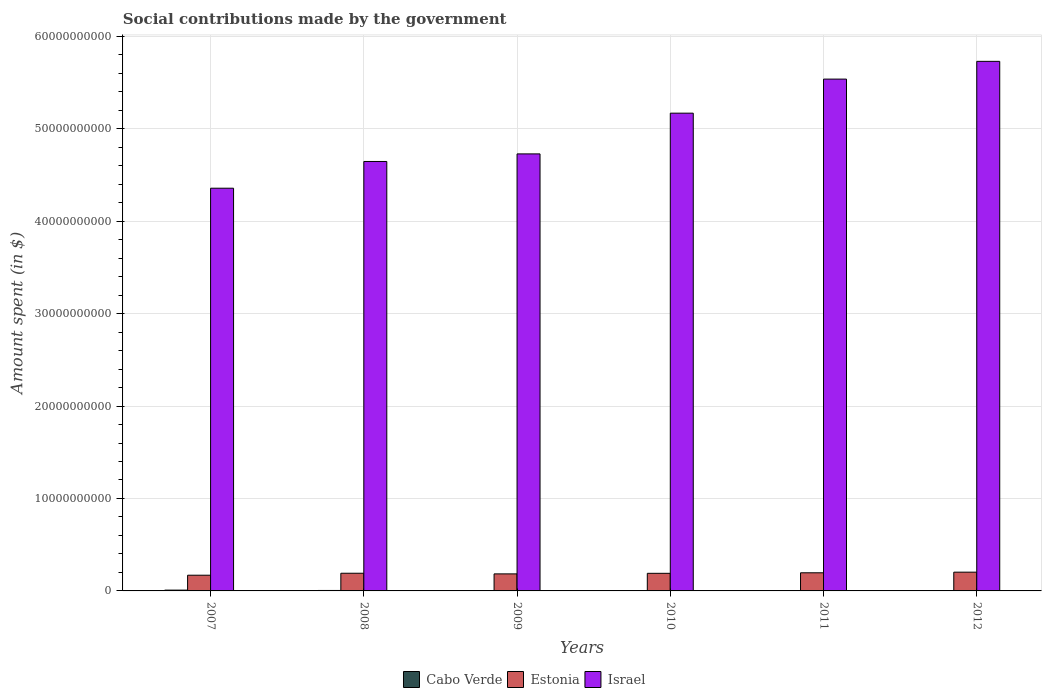How many different coloured bars are there?
Keep it short and to the point. 3. Are the number of bars per tick equal to the number of legend labels?
Keep it short and to the point. Yes. Are the number of bars on each tick of the X-axis equal?
Provide a short and direct response. Yes. How many bars are there on the 6th tick from the right?
Your answer should be compact. 3. What is the label of the 5th group of bars from the left?
Offer a very short reply. 2011. In how many cases, is the number of bars for a given year not equal to the number of legend labels?
Offer a terse response. 0. What is the amount spent on social contributions in Israel in 2009?
Offer a very short reply. 4.73e+1. Across all years, what is the maximum amount spent on social contributions in Cabo Verde?
Give a very brief answer. 8.65e+07. Across all years, what is the minimum amount spent on social contributions in Cabo Verde?
Give a very brief answer. 1.29e+07. In which year was the amount spent on social contributions in Israel maximum?
Your response must be concise. 2012. In which year was the amount spent on social contributions in Estonia minimum?
Make the answer very short. 2007. What is the total amount spent on social contributions in Estonia in the graph?
Provide a short and direct response. 1.13e+1. What is the difference between the amount spent on social contributions in Cabo Verde in 2009 and that in 2011?
Your answer should be compact. 9.01e+06. What is the difference between the amount spent on social contributions in Cabo Verde in 2011 and the amount spent on social contributions in Estonia in 2010?
Give a very brief answer. -1.87e+09. What is the average amount spent on social contributions in Estonia per year?
Offer a terse response. 1.89e+09. In the year 2011, what is the difference between the amount spent on social contributions in Cabo Verde and amount spent on social contributions in Israel?
Your answer should be compact. -5.53e+1. In how many years, is the amount spent on social contributions in Estonia greater than 26000000000 $?
Keep it short and to the point. 0. What is the ratio of the amount spent on social contributions in Estonia in 2008 to that in 2009?
Make the answer very short. 1.04. Is the difference between the amount spent on social contributions in Cabo Verde in 2008 and 2009 greater than the difference between the amount spent on social contributions in Israel in 2008 and 2009?
Ensure brevity in your answer.  Yes. What is the difference between the highest and the second highest amount spent on social contributions in Israel?
Make the answer very short. 1.92e+09. What is the difference between the highest and the lowest amount spent on social contributions in Cabo Verde?
Offer a very short reply. 7.36e+07. What does the 2nd bar from the left in 2008 represents?
Your response must be concise. Estonia. What does the 2nd bar from the right in 2008 represents?
Your answer should be compact. Estonia. How many bars are there?
Make the answer very short. 18. Does the graph contain any zero values?
Make the answer very short. No. How are the legend labels stacked?
Your answer should be compact. Horizontal. What is the title of the graph?
Your answer should be very brief. Social contributions made by the government. What is the label or title of the Y-axis?
Give a very brief answer. Amount spent (in $). What is the Amount spent (in $) of Cabo Verde in 2007?
Offer a terse response. 8.65e+07. What is the Amount spent (in $) in Estonia in 2007?
Give a very brief answer. 1.70e+09. What is the Amount spent (in $) in Israel in 2007?
Your answer should be very brief. 4.36e+1. What is the Amount spent (in $) of Cabo Verde in 2008?
Provide a succinct answer. 4.98e+07. What is the Amount spent (in $) of Estonia in 2008?
Offer a very short reply. 1.91e+09. What is the Amount spent (in $) of Israel in 2008?
Provide a succinct answer. 4.65e+1. What is the Amount spent (in $) in Cabo Verde in 2009?
Ensure brevity in your answer.  4.56e+07. What is the Amount spent (in $) of Estonia in 2009?
Give a very brief answer. 1.84e+09. What is the Amount spent (in $) in Israel in 2009?
Your response must be concise. 4.73e+1. What is the Amount spent (in $) in Cabo Verde in 2010?
Make the answer very short. 4.19e+07. What is the Amount spent (in $) in Estonia in 2010?
Make the answer very short. 1.90e+09. What is the Amount spent (in $) in Israel in 2010?
Your answer should be very brief. 5.17e+1. What is the Amount spent (in $) in Cabo Verde in 2011?
Give a very brief answer. 3.65e+07. What is the Amount spent (in $) of Estonia in 2011?
Your answer should be very brief. 1.96e+09. What is the Amount spent (in $) in Israel in 2011?
Provide a succinct answer. 5.54e+1. What is the Amount spent (in $) in Cabo Verde in 2012?
Offer a very short reply. 1.29e+07. What is the Amount spent (in $) in Estonia in 2012?
Keep it short and to the point. 2.03e+09. What is the Amount spent (in $) in Israel in 2012?
Make the answer very short. 5.73e+1. Across all years, what is the maximum Amount spent (in $) of Cabo Verde?
Provide a short and direct response. 8.65e+07. Across all years, what is the maximum Amount spent (in $) of Estonia?
Your answer should be compact. 2.03e+09. Across all years, what is the maximum Amount spent (in $) in Israel?
Offer a terse response. 5.73e+1. Across all years, what is the minimum Amount spent (in $) in Cabo Verde?
Your answer should be compact. 1.29e+07. Across all years, what is the minimum Amount spent (in $) in Estonia?
Keep it short and to the point. 1.70e+09. Across all years, what is the minimum Amount spent (in $) in Israel?
Keep it short and to the point. 4.36e+1. What is the total Amount spent (in $) of Cabo Verde in the graph?
Your answer should be compact. 2.73e+08. What is the total Amount spent (in $) of Estonia in the graph?
Provide a short and direct response. 1.13e+1. What is the total Amount spent (in $) in Israel in the graph?
Keep it short and to the point. 3.02e+11. What is the difference between the Amount spent (in $) of Cabo Verde in 2007 and that in 2008?
Make the answer very short. 3.67e+07. What is the difference between the Amount spent (in $) of Estonia in 2007 and that in 2008?
Give a very brief answer. -2.13e+08. What is the difference between the Amount spent (in $) in Israel in 2007 and that in 2008?
Ensure brevity in your answer.  -2.89e+09. What is the difference between the Amount spent (in $) in Cabo Verde in 2007 and that in 2009?
Offer a terse response. 4.10e+07. What is the difference between the Amount spent (in $) in Estonia in 2007 and that in 2009?
Your answer should be compact. -1.43e+08. What is the difference between the Amount spent (in $) of Israel in 2007 and that in 2009?
Keep it short and to the point. -3.71e+09. What is the difference between the Amount spent (in $) in Cabo Verde in 2007 and that in 2010?
Your response must be concise. 4.46e+07. What is the difference between the Amount spent (in $) of Estonia in 2007 and that in 2010?
Make the answer very short. -2.05e+08. What is the difference between the Amount spent (in $) in Israel in 2007 and that in 2010?
Give a very brief answer. -8.12e+09. What is the difference between the Amount spent (in $) of Cabo Verde in 2007 and that in 2011?
Offer a terse response. 5.00e+07. What is the difference between the Amount spent (in $) of Estonia in 2007 and that in 2011?
Your response must be concise. -2.61e+08. What is the difference between the Amount spent (in $) of Israel in 2007 and that in 2011?
Give a very brief answer. -1.18e+1. What is the difference between the Amount spent (in $) in Cabo Verde in 2007 and that in 2012?
Keep it short and to the point. 7.36e+07. What is the difference between the Amount spent (in $) in Estonia in 2007 and that in 2012?
Offer a very short reply. -3.29e+08. What is the difference between the Amount spent (in $) in Israel in 2007 and that in 2012?
Make the answer very short. -1.37e+1. What is the difference between the Amount spent (in $) of Cabo Verde in 2008 and that in 2009?
Make the answer very short. 4.24e+06. What is the difference between the Amount spent (in $) in Estonia in 2008 and that in 2009?
Ensure brevity in your answer.  6.94e+07. What is the difference between the Amount spent (in $) in Israel in 2008 and that in 2009?
Give a very brief answer. -8.21e+08. What is the difference between the Amount spent (in $) in Cabo Verde in 2008 and that in 2010?
Your answer should be compact. 7.89e+06. What is the difference between the Amount spent (in $) of Estonia in 2008 and that in 2010?
Make the answer very short. 8.00e+06. What is the difference between the Amount spent (in $) in Israel in 2008 and that in 2010?
Ensure brevity in your answer.  -5.23e+09. What is the difference between the Amount spent (in $) of Cabo Verde in 2008 and that in 2011?
Your answer should be very brief. 1.33e+07. What is the difference between the Amount spent (in $) in Estonia in 2008 and that in 2011?
Ensure brevity in your answer.  -4.88e+07. What is the difference between the Amount spent (in $) in Israel in 2008 and that in 2011?
Your answer should be very brief. -8.91e+09. What is the difference between the Amount spent (in $) in Cabo Verde in 2008 and that in 2012?
Your answer should be very brief. 3.69e+07. What is the difference between the Amount spent (in $) of Estonia in 2008 and that in 2012?
Provide a succinct answer. -1.16e+08. What is the difference between the Amount spent (in $) of Israel in 2008 and that in 2012?
Your answer should be compact. -1.08e+1. What is the difference between the Amount spent (in $) in Cabo Verde in 2009 and that in 2010?
Ensure brevity in your answer.  3.65e+06. What is the difference between the Amount spent (in $) in Estonia in 2009 and that in 2010?
Give a very brief answer. -6.14e+07. What is the difference between the Amount spent (in $) in Israel in 2009 and that in 2010?
Provide a short and direct response. -4.41e+09. What is the difference between the Amount spent (in $) of Cabo Verde in 2009 and that in 2011?
Provide a succinct answer. 9.01e+06. What is the difference between the Amount spent (in $) of Estonia in 2009 and that in 2011?
Make the answer very short. -1.18e+08. What is the difference between the Amount spent (in $) of Israel in 2009 and that in 2011?
Provide a short and direct response. -8.09e+09. What is the difference between the Amount spent (in $) of Cabo Verde in 2009 and that in 2012?
Your answer should be compact. 3.27e+07. What is the difference between the Amount spent (in $) in Estonia in 2009 and that in 2012?
Your answer should be compact. -1.86e+08. What is the difference between the Amount spent (in $) of Israel in 2009 and that in 2012?
Offer a very short reply. -1.00e+1. What is the difference between the Amount spent (in $) in Cabo Verde in 2010 and that in 2011?
Provide a succinct answer. 5.36e+06. What is the difference between the Amount spent (in $) in Estonia in 2010 and that in 2011?
Your answer should be very brief. -5.68e+07. What is the difference between the Amount spent (in $) of Israel in 2010 and that in 2011?
Keep it short and to the point. -3.69e+09. What is the difference between the Amount spent (in $) of Cabo Verde in 2010 and that in 2012?
Make the answer very short. 2.90e+07. What is the difference between the Amount spent (in $) in Estonia in 2010 and that in 2012?
Keep it short and to the point. -1.24e+08. What is the difference between the Amount spent (in $) of Israel in 2010 and that in 2012?
Your answer should be compact. -5.61e+09. What is the difference between the Amount spent (in $) in Cabo Verde in 2011 and that in 2012?
Ensure brevity in your answer.  2.36e+07. What is the difference between the Amount spent (in $) in Estonia in 2011 and that in 2012?
Keep it short and to the point. -6.76e+07. What is the difference between the Amount spent (in $) of Israel in 2011 and that in 2012?
Provide a short and direct response. -1.92e+09. What is the difference between the Amount spent (in $) of Cabo Verde in 2007 and the Amount spent (in $) of Estonia in 2008?
Offer a terse response. -1.83e+09. What is the difference between the Amount spent (in $) of Cabo Verde in 2007 and the Amount spent (in $) of Israel in 2008?
Give a very brief answer. -4.64e+1. What is the difference between the Amount spent (in $) in Estonia in 2007 and the Amount spent (in $) in Israel in 2008?
Give a very brief answer. -4.48e+1. What is the difference between the Amount spent (in $) in Cabo Verde in 2007 and the Amount spent (in $) in Estonia in 2009?
Provide a short and direct response. -1.76e+09. What is the difference between the Amount spent (in $) of Cabo Verde in 2007 and the Amount spent (in $) of Israel in 2009?
Your answer should be very brief. -4.72e+1. What is the difference between the Amount spent (in $) of Estonia in 2007 and the Amount spent (in $) of Israel in 2009?
Provide a succinct answer. -4.56e+1. What is the difference between the Amount spent (in $) of Cabo Verde in 2007 and the Amount spent (in $) of Estonia in 2010?
Keep it short and to the point. -1.82e+09. What is the difference between the Amount spent (in $) of Cabo Verde in 2007 and the Amount spent (in $) of Israel in 2010?
Your response must be concise. -5.16e+1. What is the difference between the Amount spent (in $) of Estonia in 2007 and the Amount spent (in $) of Israel in 2010?
Keep it short and to the point. -5.00e+1. What is the difference between the Amount spent (in $) of Cabo Verde in 2007 and the Amount spent (in $) of Estonia in 2011?
Offer a very short reply. -1.87e+09. What is the difference between the Amount spent (in $) in Cabo Verde in 2007 and the Amount spent (in $) in Israel in 2011?
Give a very brief answer. -5.53e+1. What is the difference between the Amount spent (in $) of Estonia in 2007 and the Amount spent (in $) of Israel in 2011?
Make the answer very short. -5.37e+1. What is the difference between the Amount spent (in $) of Cabo Verde in 2007 and the Amount spent (in $) of Estonia in 2012?
Ensure brevity in your answer.  -1.94e+09. What is the difference between the Amount spent (in $) in Cabo Verde in 2007 and the Amount spent (in $) in Israel in 2012?
Provide a succinct answer. -5.72e+1. What is the difference between the Amount spent (in $) of Estonia in 2007 and the Amount spent (in $) of Israel in 2012?
Offer a very short reply. -5.56e+1. What is the difference between the Amount spent (in $) in Cabo Verde in 2008 and the Amount spent (in $) in Estonia in 2009?
Your response must be concise. -1.79e+09. What is the difference between the Amount spent (in $) of Cabo Verde in 2008 and the Amount spent (in $) of Israel in 2009?
Ensure brevity in your answer.  -4.72e+1. What is the difference between the Amount spent (in $) of Estonia in 2008 and the Amount spent (in $) of Israel in 2009?
Offer a terse response. -4.54e+1. What is the difference between the Amount spent (in $) of Cabo Verde in 2008 and the Amount spent (in $) of Estonia in 2010?
Provide a succinct answer. -1.85e+09. What is the difference between the Amount spent (in $) in Cabo Verde in 2008 and the Amount spent (in $) in Israel in 2010?
Provide a short and direct response. -5.16e+1. What is the difference between the Amount spent (in $) in Estonia in 2008 and the Amount spent (in $) in Israel in 2010?
Make the answer very short. -4.98e+1. What is the difference between the Amount spent (in $) in Cabo Verde in 2008 and the Amount spent (in $) in Estonia in 2011?
Offer a terse response. -1.91e+09. What is the difference between the Amount spent (in $) of Cabo Verde in 2008 and the Amount spent (in $) of Israel in 2011?
Your answer should be very brief. -5.53e+1. What is the difference between the Amount spent (in $) of Estonia in 2008 and the Amount spent (in $) of Israel in 2011?
Ensure brevity in your answer.  -5.35e+1. What is the difference between the Amount spent (in $) of Cabo Verde in 2008 and the Amount spent (in $) of Estonia in 2012?
Provide a succinct answer. -1.98e+09. What is the difference between the Amount spent (in $) in Cabo Verde in 2008 and the Amount spent (in $) in Israel in 2012?
Offer a terse response. -5.72e+1. What is the difference between the Amount spent (in $) in Estonia in 2008 and the Amount spent (in $) in Israel in 2012?
Make the answer very short. -5.54e+1. What is the difference between the Amount spent (in $) in Cabo Verde in 2009 and the Amount spent (in $) in Estonia in 2010?
Your response must be concise. -1.86e+09. What is the difference between the Amount spent (in $) in Cabo Verde in 2009 and the Amount spent (in $) in Israel in 2010?
Your answer should be very brief. -5.16e+1. What is the difference between the Amount spent (in $) in Estonia in 2009 and the Amount spent (in $) in Israel in 2010?
Offer a very short reply. -4.98e+1. What is the difference between the Amount spent (in $) of Cabo Verde in 2009 and the Amount spent (in $) of Estonia in 2011?
Provide a succinct answer. -1.92e+09. What is the difference between the Amount spent (in $) of Cabo Verde in 2009 and the Amount spent (in $) of Israel in 2011?
Keep it short and to the point. -5.53e+1. What is the difference between the Amount spent (in $) in Estonia in 2009 and the Amount spent (in $) in Israel in 2011?
Your answer should be very brief. -5.35e+1. What is the difference between the Amount spent (in $) of Cabo Verde in 2009 and the Amount spent (in $) of Estonia in 2012?
Provide a short and direct response. -1.98e+09. What is the difference between the Amount spent (in $) of Cabo Verde in 2009 and the Amount spent (in $) of Israel in 2012?
Make the answer very short. -5.72e+1. What is the difference between the Amount spent (in $) in Estonia in 2009 and the Amount spent (in $) in Israel in 2012?
Your answer should be very brief. -5.54e+1. What is the difference between the Amount spent (in $) of Cabo Verde in 2010 and the Amount spent (in $) of Estonia in 2011?
Your answer should be very brief. -1.92e+09. What is the difference between the Amount spent (in $) of Cabo Verde in 2010 and the Amount spent (in $) of Israel in 2011?
Ensure brevity in your answer.  -5.53e+1. What is the difference between the Amount spent (in $) of Estonia in 2010 and the Amount spent (in $) of Israel in 2011?
Offer a terse response. -5.35e+1. What is the difference between the Amount spent (in $) of Cabo Verde in 2010 and the Amount spent (in $) of Estonia in 2012?
Your response must be concise. -1.99e+09. What is the difference between the Amount spent (in $) in Cabo Verde in 2010 and the Amount spent (in $) in Israel in 2012?
Provide a short and direct response. -5.72e+1. What is the difference between the Amount spent (in $) in Estonia in 2010 and the Amount spent (in $) in Israel in 2012?
Keep it short and to the point. -5.54e+1. What is the difference between the Amount spent (in $) of Cabo Verde in 2011 and the Amount spent (in $) of Estonia in 2012?
Your answer should be very brief. -1.99e+09. What is the difference between the Amount spent (in $) of Cabo Verde in 2011 and the Amount spent (in $) of Israel in 2012?
Keep it short and to the point. -5.72e+1. What is the difference between the Amount spent (in $) of Estonia in 2011 and the Amount spent (in $) of Israel in 2012?
Keep it short and to the point. -5.53e+1. What is the average Amount spent (in $) of Cabo Verde per year?
Your answer should be compact. 4.55e+07. What is the average Amount spent (in $) of Estonia per year?
Your answer should be compact. 1.89e+09. What is the average Amount spent (in $) of Israel per year?
Offer a very short reply. 5.03e+1. In the year 2007, what is the difference between the Amount spent (in $) in Cabo Verde and Amount spent (in $) in Estonia?
Your answer should be very brief. -1.61e+09. In the year 2007, what is the difference between the Amount spent (in $) of Cabo Verde and Amount spent (in $) of Israel?
Make the answer very short. -4.35e+1. In the year 2007, what is the difference between the Amount spent (in $) in Estonia and Amount spent (in $) in Israel?
Give a very brief answer. -4.19e+1. In the year 2008, what is the difference between the Amount spent (in $) of Cabo Verde and Amount spent (in $) of Estonia?
Offer a terse response. -1.86e+09. In the year 2008, what is the difference between the Amount spent (in $) of Cabo Verde and Amount spent (in $) of Israel?
Your answer should be very brief. -4.64e+1. In the year 2008, what is the difference between the Amount spent (in $) in Estonia and Amount spent (in $) in Israel?
Offer a very short reply. -4.45e+1. In the year 2009, what is the difference between the Amount spent (in $) in Cabo Verde and Amount spent (in $) in Estonia?
Provide a short and direct response. -1.80e+09. In the year 2009, what is the difference between the Amount spent (in $) in Cabo Verde and Amount spent (in $) in Israel?
Provide a succinct answer. -4.72e+1. In the year 2009, what is the difference between the Amount spent (in $) in Estonia and Amount spent (in $) in Israel?
Keep it short and to the point. -4.54e+1. In the year 2010, what is the difference between the Amount spent (in $) in Cabo Verde and Amount spent (in $) in Estonia?
Offer a very short reply. -1.86e+09. In the year 2010, what is the difference between the Amount spent (in $) of Cabo Verde and Amount spent (in $) of Israel?
Give a very brief answer. -5.16e+1. In the year 2010, what is the difference between the Amount spent (in $) in Estonia and Amount spent (in $) in Israel?
Make the answer very short. -4.98e+1. In the year 2011, what is the difference between the Amount spent (in $) of Cabo Verde and Amount spent (in $) of Estonia?
Keep it short and to the point. -1.92e+09. In the year 2011, what is the difference between the Amount spent (in $) in Cabo Verde and Amount spent (in $) in Israel?
Your answer should be very brief. -5.53e+1. In the year 2011, what is the difference between the Amount spent (in $) of Estonia and Amount spent (in $) of Israel?
Your answer should be very brief. -5.34e+1. In the year 2012, what is the difference between the Amount spent (in $) of Cabo Verde and Amount spent (in $) of Estonia?
Your answer should be very brief. -2.02e+09. In the year 2012, what is the difference between the Amount spent (in $) in Cabo Verde and Amount spent (in $) in Israel?
Offer a very short reply. -5.73e+1. In the year 2012, what is the difference between the Amount spent (in $) of Estonia and Amount spent (in $) of Israel?
Ensure brevity in your answer.  -5.53e+1. What is the ratio of the Amount spent (in $) in Cabo Verde in 2007 to that in 2008?
Your answer should be compact. 1.74. What is the ratio of the Amount spent (in $) of Estonia in 2007 to that in 2008?
Your answer should be compact. 0.89. What is the ratio of the Amount spent (in $) of Israel in 2007 to that in 2008?
Offer a terse response. 0.94. What is the ratio of the Amount spent (in $) of Cabo Verde in 2007 to that in 2009?
Provide a short and direct response. 1.9. What is the ratio of the Amount spent (in $) in Estonia in 2007 to that in 2009?
Your answer should be compact. 0.92. What is the ratio of the Amount spent (in $) in Israel in 2007 to that in 2009?
Your response must be concise. 0.92. What is the ratio of the Amount spent (in $) in Cabo Verde in 2007 to that in 2010?
Keep it short and to the point. 2.06. What is the ratio of the Amount spent (in $) in Estonia in 2007 to that in 2010?
Your answer should be compact. 0.89. What is the ratio of the Amount spent (in $) of Israel in 2007 to that in 2010?
Give a very brief answer. 0.84. What is the ratio of the Amount spent (in $) of Cabo Verde in 2007 to that in 2011?
Provide a short and direct response. 2.37. What is the ratio of the Amount spent (in $) in Estonia in 2007 to that in 2011?
Offer a very short reply. 0.87. What is the ratio of the Amount spent (in $) of Israel in 2007 to that in 2011?
Provide a succinct answer. 0.79. What is the ratio of the Amount spent (in $) of Cabo Verde in 2007 to that in 2012?
Your response must be concise. 6.71. What is the ratio of the Amount spent (in $) in Estonia in 2007 to that in 2012?
Keep it short and to the point. 0.84. What is the ratio of the Amount spent (in $) in Israel in 2007 to that in 2012?
Make the answer very short. 0.76. What is the ratio of the Amount spent (in $) of Cabo Verde in 2008 to that in 2009?
Provide a short and direct response. 1.09. What is the ratio of the Amount spent (in $) in Estonia in 2008 to that in 2009?
Provide a short and direct response. 1.04. What is the ratio of the Amount spent (in $) in Israel in 2008 to that in 2009?
Keep it short and to the point. 0.98. What is the ratio of the Amount spent (in $) in Cabo Verde in 2008 to that in 2010?
Provide a short and direct response. 1.19. What is the ratio of the Amount spent (in $) of Israel in 2008 to that in 2010?
Your response must be concise. 0.9. What is the ratio of the Amount spent (in $) in Cabo Verde in 2008 to that in 2011?
Offer a very short reply. 1.36. What is the ratio of the Amount spent (in $) of Estonia in 2008 to that in 2011?
Provide a short and direct response. 0.98. What is the ratio of the Amount spent (in $) in Israel in 2008 to that in 2011?
Offer a very short reply. 0.84. What is the ratio of the Amount spent (in $) of Cabo Verde in 2008 to that in 2012?
Provide a short and direct response. 3.86. What is the ratio of the Amount spent (in $) of Estonia in 2008 to that in 2012?
Offer a terse response. 0.94. What is the ratio of the Amount spent (in $) in Israel in 2008 to that in 2012?
Offer a terse response. 0.81. What is the ratio of the Amount spent (in $) in Cabo Verde in 2009 to that in 2010?
Your response must be concise. 1.09. What is the ratio of the Amount spent (in $) in Estonia in 2009 to that in 2010?
Ensure brevity in your answer.  0.97. What is the ratio of the Amount spent (in $) of Israel in 2009 to that in 2010?
Ensure brevity in your answer.  0.91. What is the ratio of the Amount spent (in $) in Cabo Verde in 2009 to that in 2011?
Provide a succinct answer. 1.25. What is the ratio of the Amount spent (in $) in Estonia in 2009 to that in 2011?
Your response must be concise. 0.94. What is the ratio of the Amount spent (in $) of Israel in 2009 to that in 2011?
Offer a terse response. 0.85. What is the ratio of the Amount spent (in $) of Cabo Verde in 2009 to that in 2012?
Keep it short and to the point. 3.53. What is the ratio of the Amount spent (in $) of Estonia in 2009 to that in 2012?
Provide a short and direct response. 0.91. What is the ratio of the Amount spent (in $) of Israel in 2009 to that in 2012?
Provide a short and direct response. 0.83. What is the ratio of the Amount spent (in $) in Cabo Verde in 2010 to that in 2011?
Your answer should be compact. 1.15. What is the ratio of the Amount spent (in $) of Estonia in 2010 to that in 2011?
Offer a terse response. 0.97. What is the ratio of the Amount spent (in $) of Israel in 2010 to that in 2011?
Provide a succinct answer. 0.93. What is the ratio of the Amount spent (in $) in Cabo Verde in 2010 to that in 2012?
Provide a succinct answer. 3.25. What is the ratio of the Amount spent (in $) in Estonia in 2010 to that in 2012?
Give a very brief answer. 0.94. What is the ratio of the Amount spent (in $) in Israel in 2010 to that in 2012?
Provide a short and direct response. 0.9. What is the ratio of the Amount spent (in $) in Cabo Verde in 2011 to that in 2012?
Keep it short and to the point. 2.83. What is the ratio of the Amount spent (in $) of Estonia in 2011 to that in 2012?
Your response must be concise. 0.97. What is the ratio of the Amount spent (in $) of Israel in 2011 to that in 2012?
Keep it short and to the point. 0.97. What is the difference between the highest and the second highest Amount spent (in $) in Cabo Verde?
Give a very brief answer. 3.67e+07. What is the difference between the highest and the second highest Amount spent (in $) of Estonia?
Provide a short and direct response. 6.76e+07. What is the difference between the highest and the second highest Amount spent (in $) of Israel?
Offer a terse response. 1.92e+09. What is the difference between the highest and the lowest Amount spent (in $) in Cabo Verde?
Offer a very short reply. 7.36e+07. What is the difference between the highest and the lowest Amount spent (in $) of Estonia?
Offer a very short reply. 3.29e+08. What is the difference between the highest and the lowest Amount spent (in $) of Israel?
Your answer should be compact. 1.37e+1. 